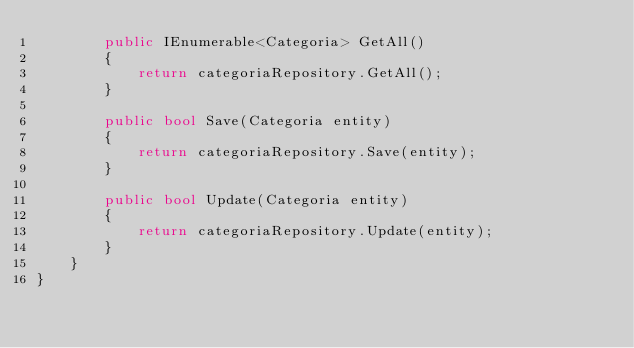Convert code to text. <code><loc_0><loc_0><loc_500><loc_500><_C#_>        public IEnumerable<Categoria> GetAll()
        {
            return categoriaRepository.GetAll();
        }

        public bool Save(Categoria entity)
        {
            return categoriaRepository.Save(entity);
        }

        public bool Update(Categoria entity)
        {
            return categoriaRepository.Update(entity);
        }
    }
}</code> 